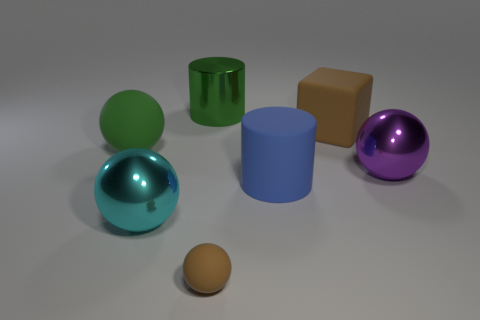Subtract all large balls. How many balls are left? 1 Subtract all cyan balls. How many balls are left? 3 Subtract all spheres. How many objects are left? 3 Subtract all gray cylinders. How many purple balls are left? 1 Subtract all large cyan balls. Subtract all large blue matte objects. How many objects are left? 5 Add 6 large purple things. How many large purple things are left? 7 Add 4 tiny purple matte spheres. How many tiny purple matte spheres exist? 4 Add 2 large red matte objects. How many objects exist? 9 Subtract 0 yellow cylinders. How many objects are left? 7 Subtract 1 cubes. How many cubes are left? 0 